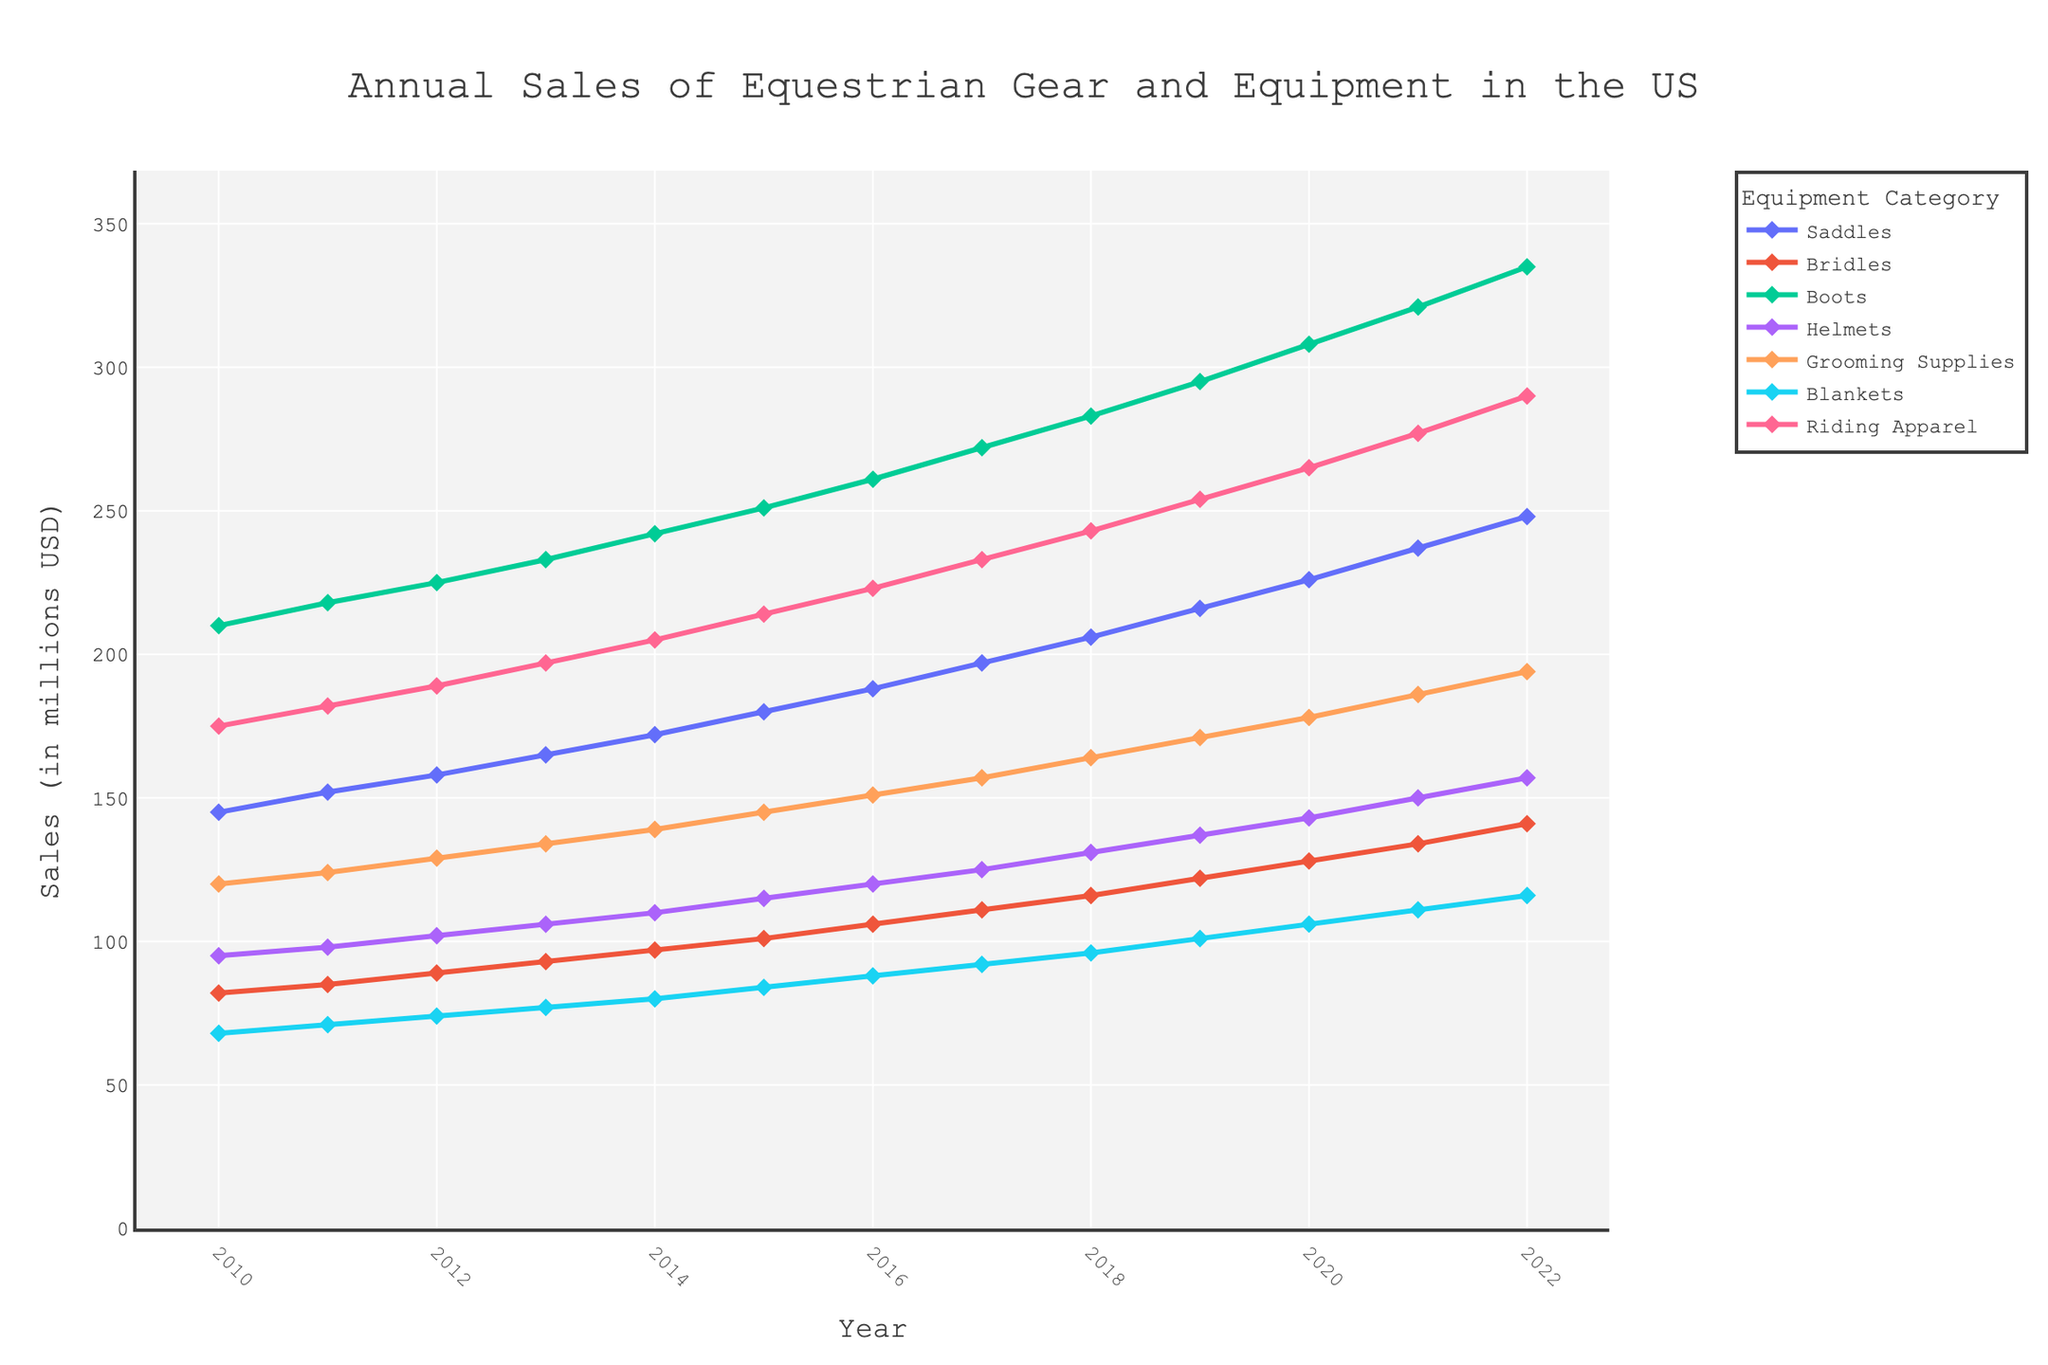what is the total sales of Saddles and Bridles in 2020? Add the sales of Saddles (226) and Bridles (128) in 2020: 226 + 128 = 354
Answer: 354 Which category had the highest sales in 2014? Look at the year 2014, and check the sales for all categories. The Boots category has the highest sales at 242 million USD.
Answer: Boots How much did the sales of Riding Apparel increase from 2010 to 2022? Find the sales of Riding Apparel in 2010 (175) and 2022 (290). Subtract the earlier value from the latter: 290 - 175 = 115
Answer: 115 In which year did Helmets first surpass 100 million USD in sales? Look at the sales data for Helmets over the years and identify the first year it exceeds 100. In 2015, the sales are 115 million USD.
Answer: 2015 What is the difference in sales between Grooming Supplies and Blankets in 2022? Subtract the sales of Blankets (116) from the sales of Grooming Supplies (194): 194 - 116 = 78
Answer: 78 If Saddles and Boots are combined, in which year did their total sales exceed 400 million USD? Add the sales of Saddles and Boots for each year until their combined sales exceed 400. In 2012, Saddles (158) + Boots (225) = 383; in 2013, Saddles (165) + Boots (233) = 398; in 2014, Saddles (172) + Boots (242) = 414. Hence, they first surpassed 400 million USD in 2014.
Answer: 2014 What is the average annual sales of Helmets from 2010 to 2022? Sum the annual sales of Helmets over the years and then divide by the number of years (13). (95+98+102+106+110+115+120+125+131+137+143+150+157)/13 = 119.54
Answer: 119.54 Which category shows the constant increase in sales every year from 2010 to 2022? Observe the trend lines of each category and note which line consistently goes up year-to-year. Riding Apparel shows a steady increase every year from 2010 to 2022.
Answer: Riding Apparel In which year did the sales of Bridles and Helmets become equal? Compare the sales of Bridles and Helmets annually. They both are equal at 150 in the year 2021.
Answer: 2021 Which category had the smallest sales increase from 2010 to 2022? Calculate the increase for each category by subtracting their 2010 sales from their 2022 sales. Blankets had the smallest increase, from 68 in 2010 to 116 in 2022, an increase of 48.
Answer: Blankets 